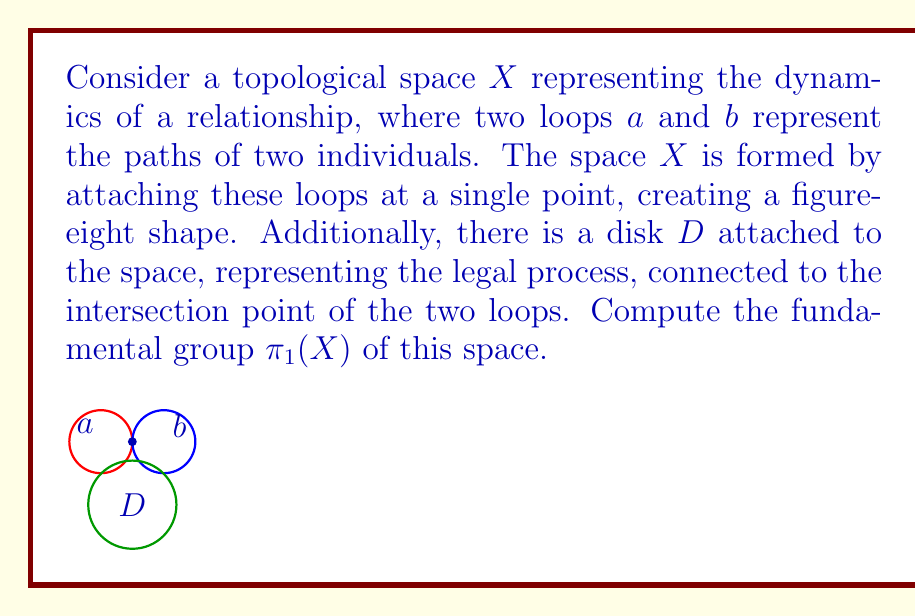Teach me how to tackle this problem. To compute the fundamental group of $X$, we'll use the Seifert-van Kampen theorem. Let's break this down step-by-step:

1) First, we need to choose our open sets. Let:
   $U$ = the figure-eight shape (two loops $a$ and $b$)
   $V$ = the disk $D$ and a small neighborhood around the attachment point

2) $U \cap V$ is homotopy equivalent to a point, so $\pi_1(U \cap V)$ is trivial.

3) We know that $\pi_1(U)$ is isomorphic to the free group on two generators, $F_2 = \langle a, b \rangle$, where $a$ and $b$ represent the two loops.

4) $\pi_1(V)$ is trivial, as $V$ is contractible (it's essentially a disk).

5) By the Seifert-van Kampen theorem, $\pi_1(X)$ is the pushout of the diagram:

   $$\pi_1(U \cap V) \rightarrow \pi_1(U)$$
   $$\pi_1(U \cap V) \rightarrow \pi_1(V)$$

6) Since $\pi_1(U \cap V)$ and $\pi_1(V)$ are both trivial, this pushout is simply $\pi_1(U)$.

Therefore, the fundamental group of $X$ is isomorphic to the free group on two generators, $F_2 = \langle a, b \rangle$.

This result can be interpreted in the context of the given persona: the two loops represent the paths of the two individuals in the relationship, which remain distinct and "free" despite the legal process (represented by the disk) that connects them at a single point.
Answer: $\pi_1(X) \cong F_2 = \langle a, b \rangle$ 